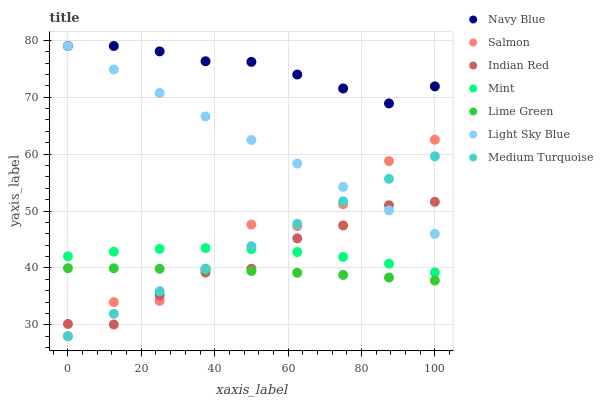Does Lime Green have the minimum area under the curve?
Answer yes or no. Yes. Does Navy Blue have the maximum area under the curve?
Answer yes or no. Yes. Does Salmon have the minimum area under the curve?
Answer yes or no. No. Does Salmon have the maximum area under the curve?
Answer yes or no. No. Is Medium Turquoise the smoothest?
Answer yes or no. Yes. Is Salmon the roughest?
Answer yes or no. Yes. Is Navy Blue the smoothest?
Answer yes or no. No. Is Navy Blue the roughest?
Answer yes or no. No. Does Medium Turquoise have the lowest value?
Answer yes or no. Yes. Does Navy Blue have the lowest value?
Answer yes or no. No. Does Light Sky Blue have the highest value?
Answer yes or no. Yes. Does Salmon have the highest value?
Answer yes or no. No. Is Salmon less than Navy Blue?
Answer yes or no. Yes. Is Navy Blue greater than Mint?
Answer yes or no. Yes. Does Indian Red intersect Light Sky Blue?
Answer yes or no. Yes. Is Indian Red less than Light Sky Blue?
Answer yes or no. No. Is Indian Red greater than Light Sky Blue?
Answer yes or no. No. Does Salmon intersect Navy Blue?
Answer yes or no. No. 